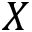Convert formula to latex. <formula><loc_0><loc_0><loc_500><loc_500>X</formula> 